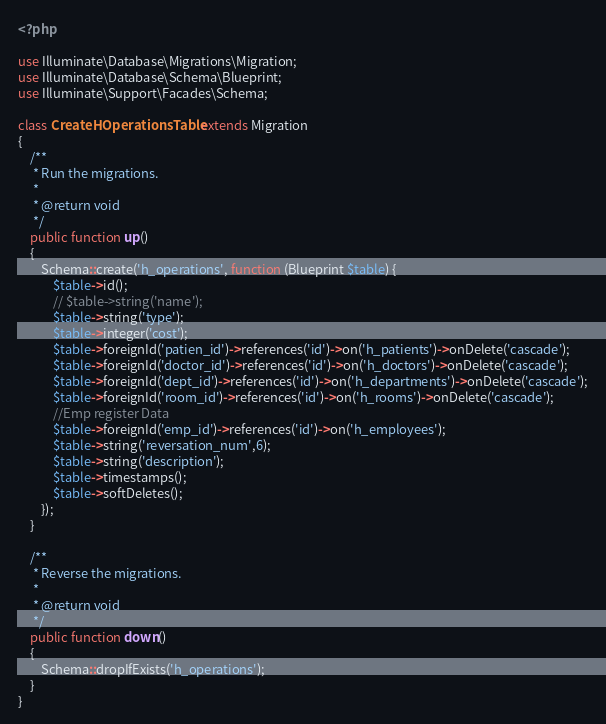Convert code to text. <code><loc_0><loc_0><loc_500><loc_500><_PHP_><?php

use Illuminate\Database\Migrations\Migration;
use Illuminate\Database\Schema\Blueprint;
use Illuminate\Support\Facades\Schema;

class CreateHOperationsTable extends Migration
{
    /**
     * Run the migrations.
     *
     * @return void
     */
    public function up()
    {
        Schema::create('h_operations', function (Blueprint $table) {
            $table->id();
            // $table->string('name');
            $table->string('type');
            $table->integer('cost');
            $table->foreignId('patien_id')->references('id')->on('h_patients')->onDelete('cascade');
            $table->foreignId('doctor_id')->references('id')->on('h_doctors')->onDelete('cascade');
            $table->foreignId('dept_id')->references('id')->on('h_departments')->onDelete('cascade');
            $table->foreignId('room_id')->references('id')->on('h_rooms')->onDelete('cascade');
            //Emp register Data
            $table->foreignId('emp_id')->references('id')->on('h_employees');
            $table->string('reversation_num',6);
            $table->string('description');
            $table->timestamps();
            $table->softDeletes();
        });
    }

    /**
     * Reverse the migrations.
     *
     * @return void
     */
    public function down()
    {
        Schema::dropIfExists('h_operations');
    }
}
</code> 